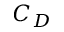Convert formula to latex. <formula><loc_0><loc_0><loc_500><loc_500>C _ { D }</formula> 